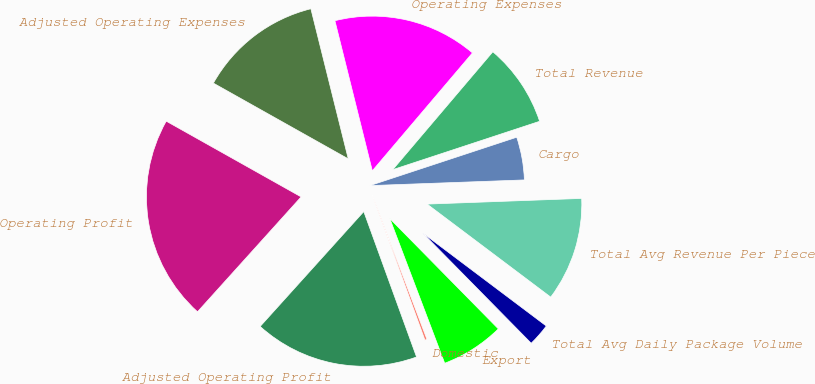Convert chart. <chart><loc_0><loc_0><loc_500><loc_500><pie_chart><fcel>Domestic<fcel>Export<fcel>Total Avg Daily Package Volume<fcel>Total Avg Revenue Per Piece<fcel>Cargo<fcel>Total Revenue<fcel>Operating Expenses<fcel>Adjusted Operating Expenses<fcel>Operating Profit<fcel>Adjusted Operating Profit<nl><fcel>0.23%<fcel>6.6%<fcel>2.36%<fcel>10.85%<fcel>4.48%<fcel>8.73%<fcel>15.09%<fcel>12.97%<fcel>21.46%<fcel>17.22%<nl></chart> 